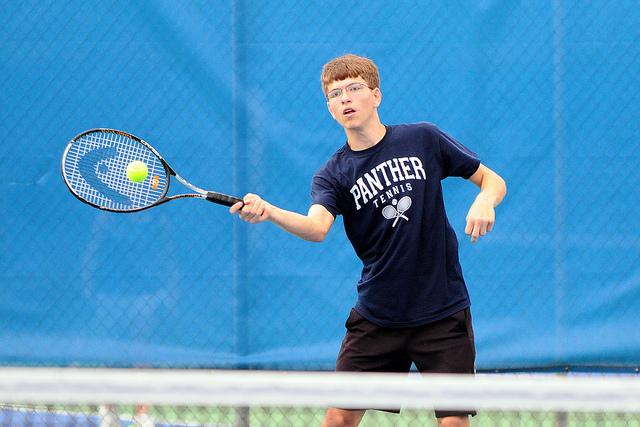Is the boy going to hit the tennis ball?
Concise answer only. Yes. Is this boy a blonde?
Keep it brief. No. What type of ball is that?
Give a very brief answer. Tennis. 